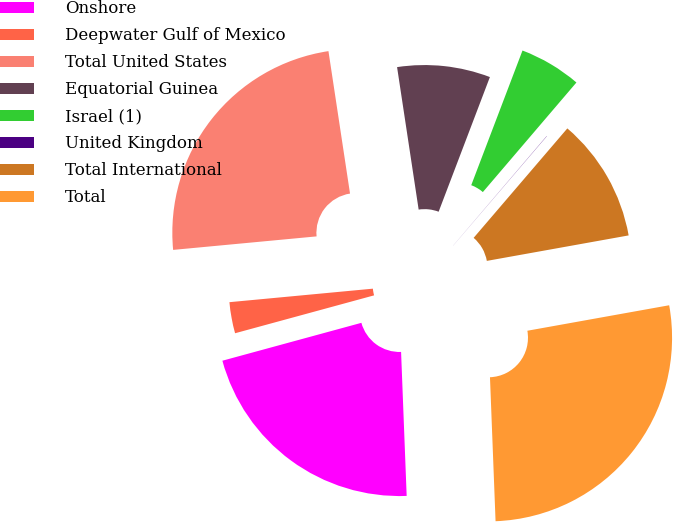<chart> <loc_0><loc_0><loc_500><loc_500><pie_chart><fcel>Onshore<fcel>Deepwater Gulf of Mexico<fcel>Total United States<fcel>Equatorial Guinea<fcel>Israel (1)<fcel>United Kingdom<fcel>Total International<fcel>Total<nl><fcel>21.38%<fcel>2.74%<fcel>24.1%<fcel>8.18%<fcel>5.46%<fcel>0.02%<fcel>10.9%<fcel>27.21%<nl></chart> 